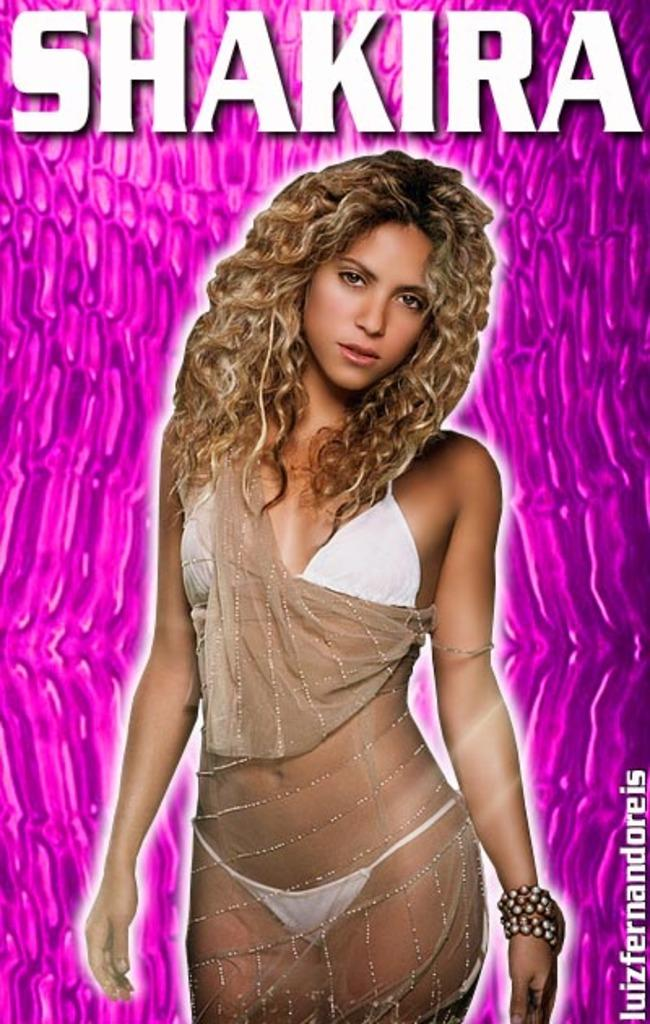Who is present in the image? There is a woman in the image. What color is the background of the image? The background of the image is pink. What else can be seen in the image besides the woman? There is text visible at the top of the image. How many ducks are present in the image? There are no ducks present in the image. What type of flesh can be seen in the image? There is no flesh visible in the image. 